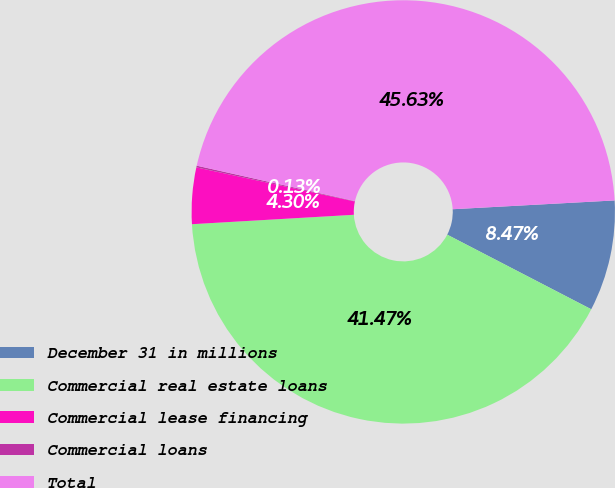<chart> <loc_0><loc_0><loc_500><loc_500><pie_chart><fcel>December 31 in millions<fcel>Commercial real estate loans<fcel>Commercial lease financing<fcel>Commercial loans<fcel>Total<nl><fcel>8.47%<fcel>41.47%<fcel>4.3%<fcel>0.13%<fcel>45.63%<nl></chart> 